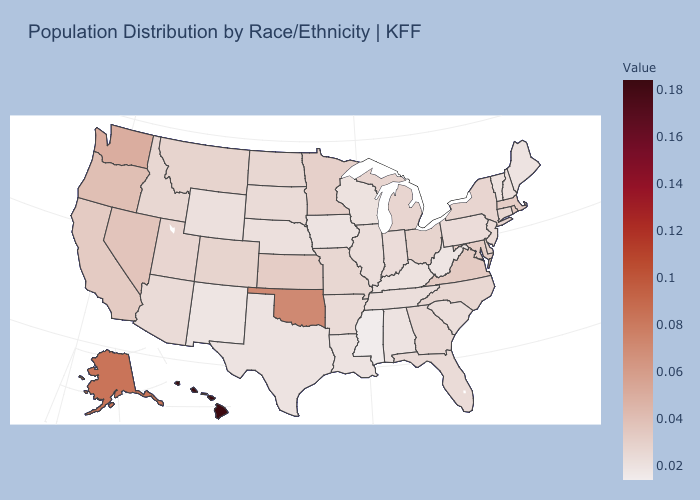Does Oregon have a lower value than Oklahoma?
Answer briefly. Yes. Does Hawaii have the highest value in the USA?
Quick response, please. Yes. 